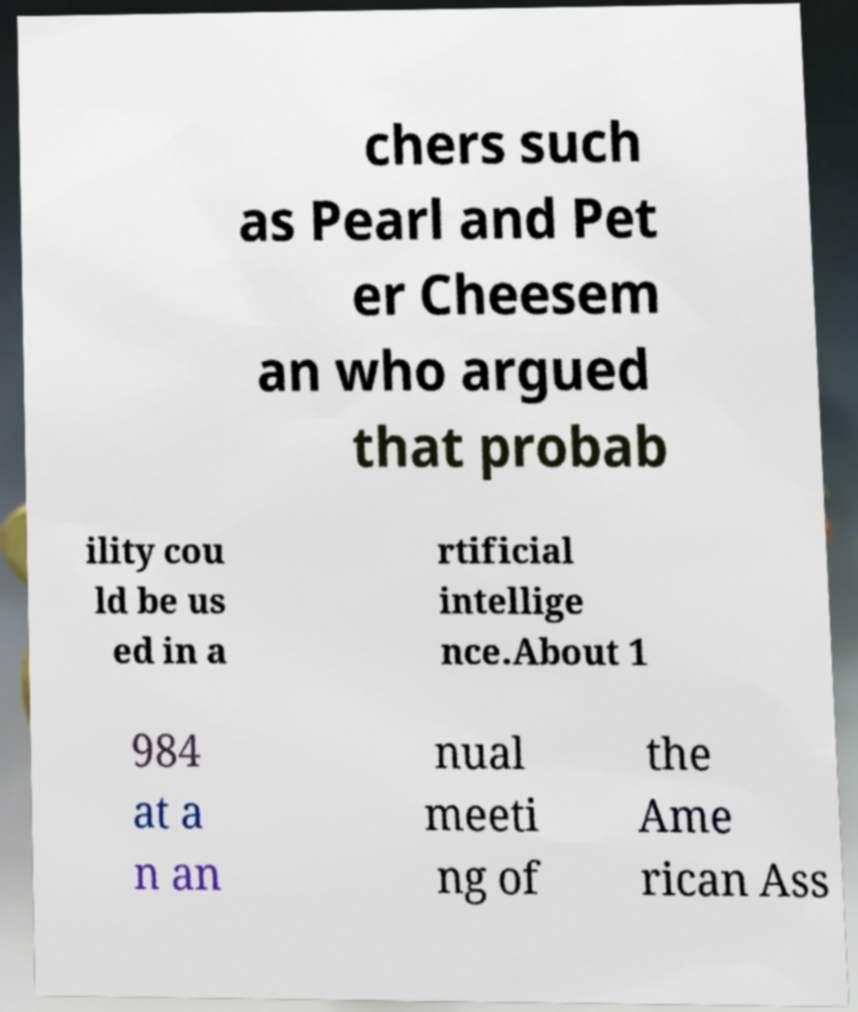Can you read and provide the text displayed in the image?This photo seems to have some interesting text. Can you extract and type it out for me? chers such as Pearl and Pet er Cheesem an who argued that probab ility cou ld be us ed in a rtificial intellige nce.About 1 984 at a n an nual meeti ng of the Ame rican Ass 